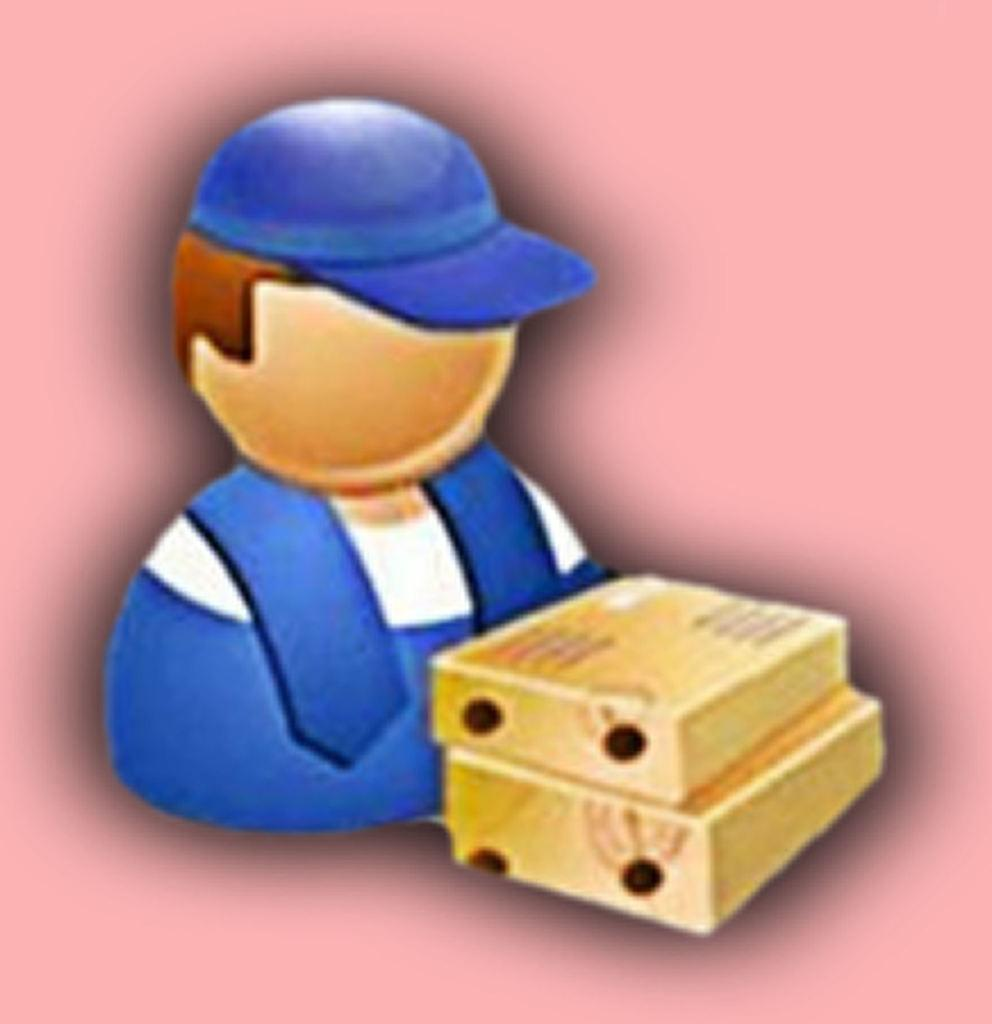What is the main subject of the image? There is a depiction of a person in the image. What objects can be seen in the image besides the person? There are two boxes and a cap visible in the image. How many ladybugs are crawling on the person in the image? There are no ladybugs present in the image. What type of sponge is being used by the person in the image? There is no sponge visible in the image. 